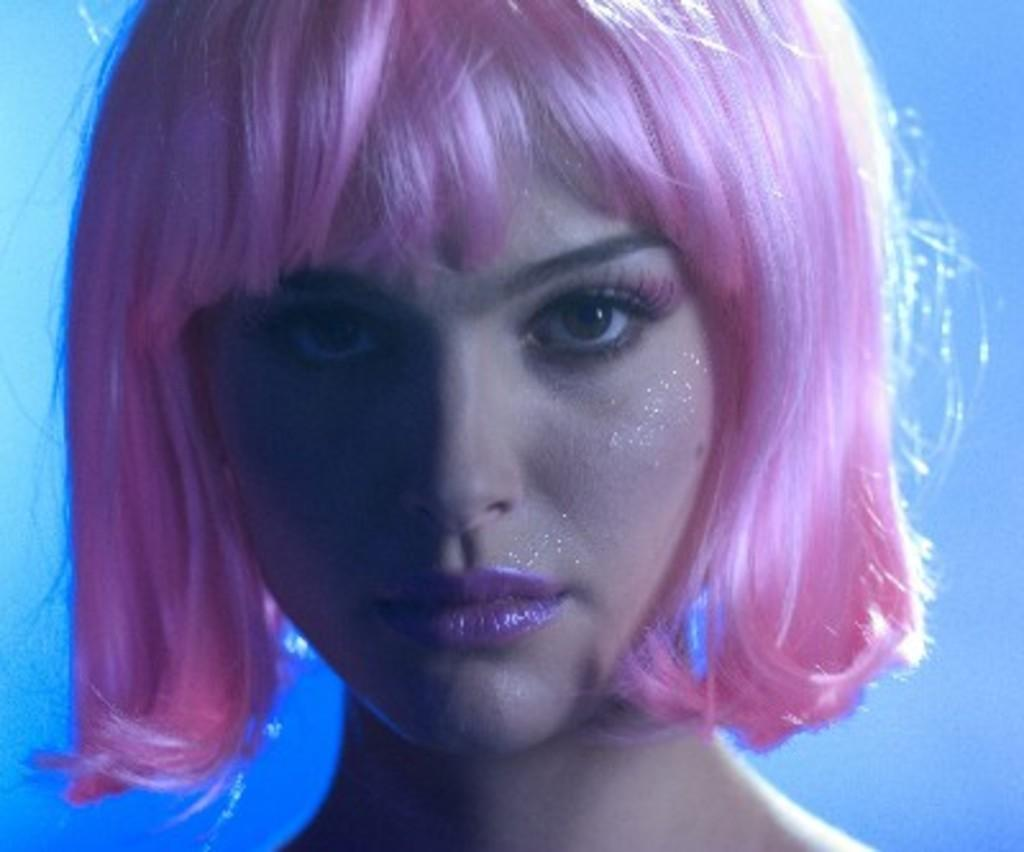Who is the main subject in the image? There is a girl in the image. What color is the girl's hair? The girl's hair is pink. What is the girl doing in the image? The girl is looking at the camera. What color is the background of the image? The background of the image is blue. What type of yoke is the girl holding in the image? There is no yoke present in the image. Can you tell me how many pumps are visible in the image? There are no pumps visible in the image. 